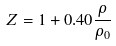<formula> <loc_0><loc_0><loc_500><loc_500>Z = 1 + 0 . 4 0 \frac { \rho } { \rho _ { 0 } }</formula> 